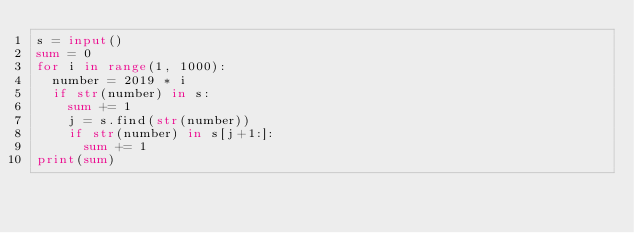<code> <loc_0><loc_0><loc_500><loc_500><_Python_>s = input()
sum = 0
for i in range(1, 1000):
  number = 2019 * i
  if str(number) in s:
    sum += 1
    j = s.find(str(number))
    if str(number) in s[j+1:]:
      sum += 1
print(sum)</code> 